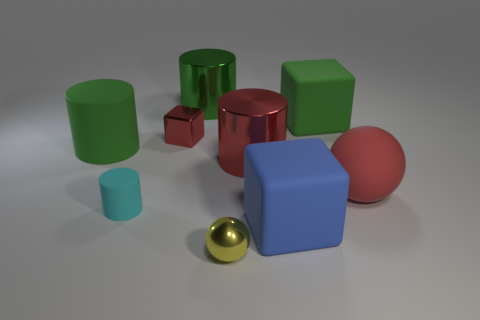Subtract all green blocks. How many blocks are left? 2 Subtract 1 balls. How many balls are left? 1 Subtract all gray cubes. Subtract all blue cylinders. How many cubes are left? 3 Subtract all blue blocks. How many red cylinders are left? 1 Subtract all green matte blocks. Subtract all large balls. How many objects are left? 7 Add 4 big cylinders. How many big cylinders are left? 7 Add 9 tiny cyan blocks. How many tiny cyan blocks exist? 9 Subtract all red balls. How many balls are left? 1 Subtract 0 brown balls. How many objects are left? 9 Subtract all cylinders. How many objects are left? 5 